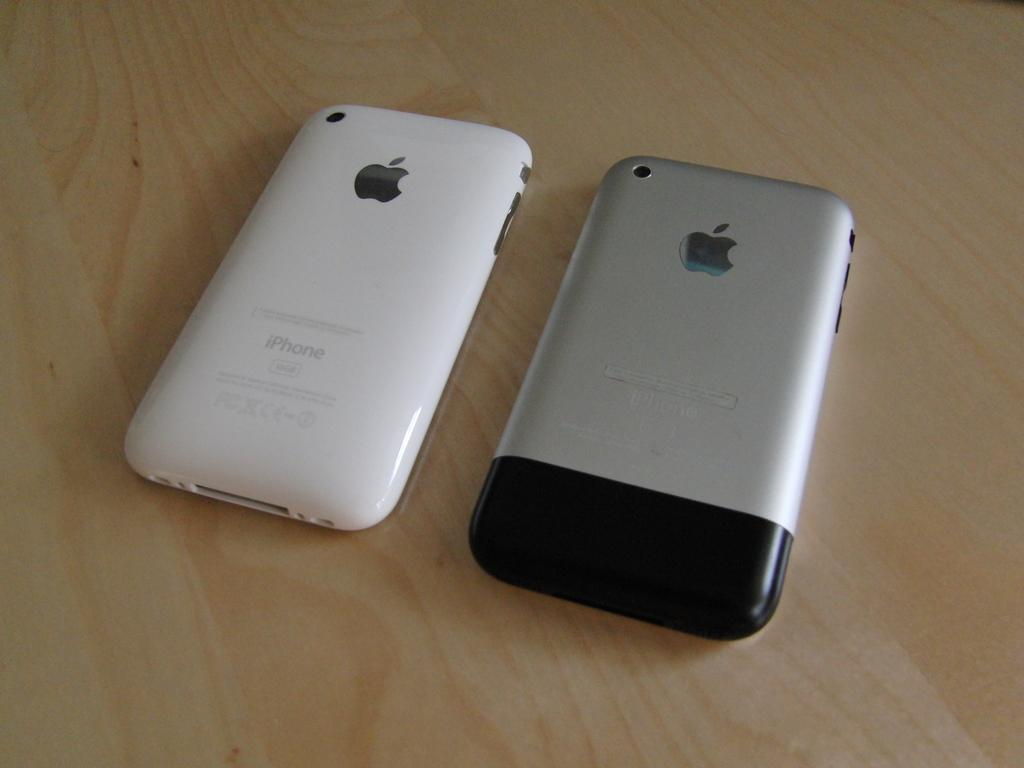Provide a one-sentence caption for the provided image. Two iPhone's are face down on the wooden surface. 